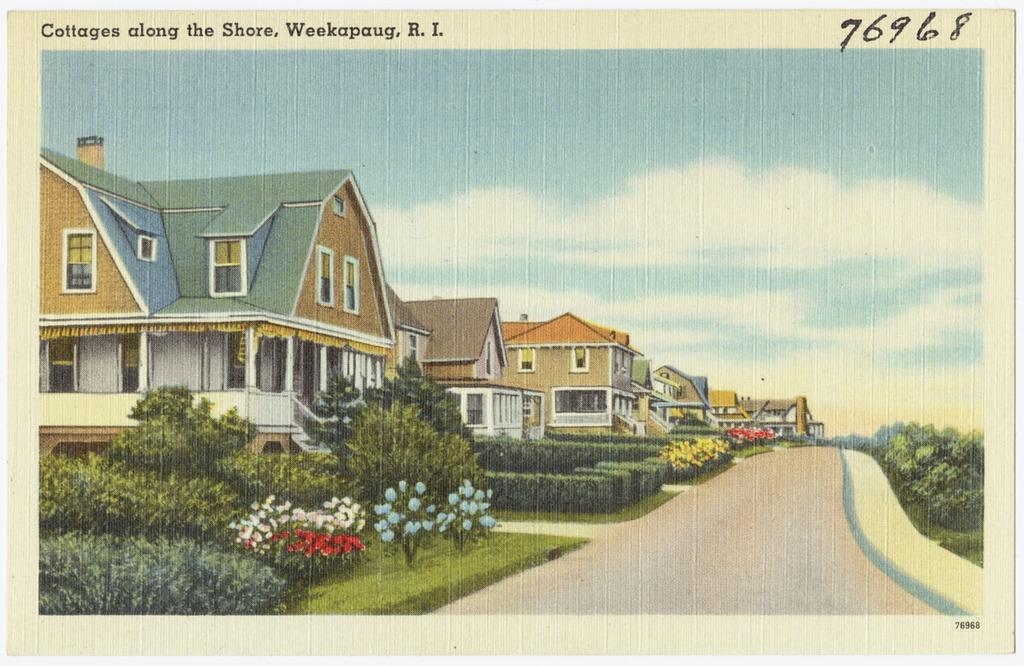What type of image is being described? The image is a printed picture. What structures can be seen in the image? There are houses in the image. What type of vegetation is present in the image? There are trees and plants on the ground in the image. What is the ground covered with in the image? The ground is covered with grass in the image. How would you describe the sky in the image? The sky is blue and cloudy in the image. Can you see a light bulb being turned on in the image? There is no light bulb or any indication of electricity in the image. Are there any people kissing in the image? There is no indication of people or any human activity in the image. 